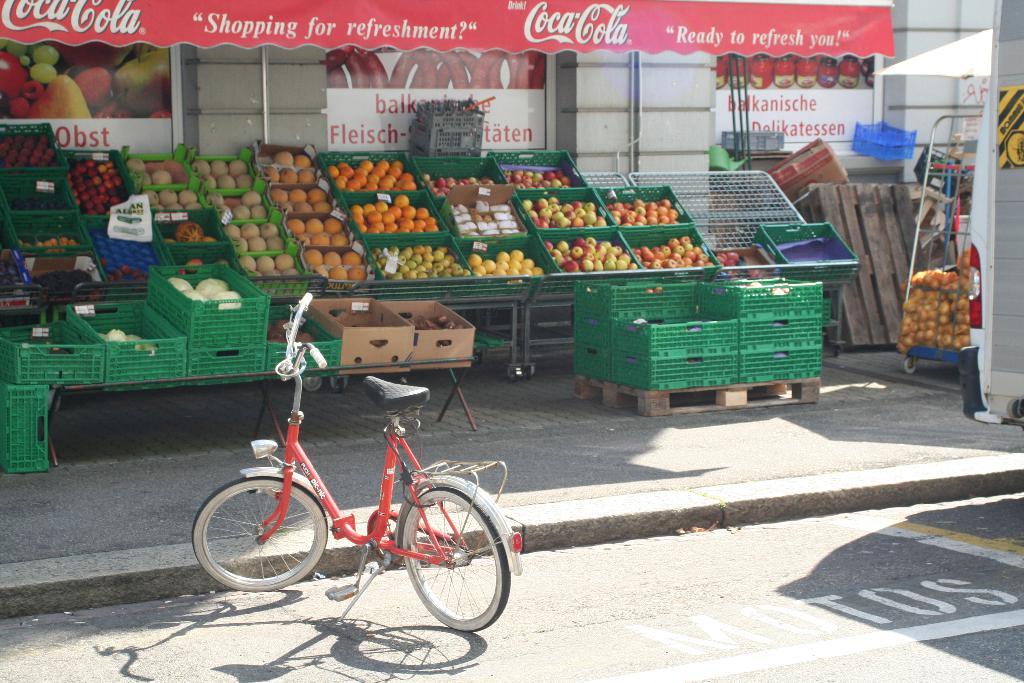What soda brand is sold here?
Keep it short and to the point. Coca cola. 